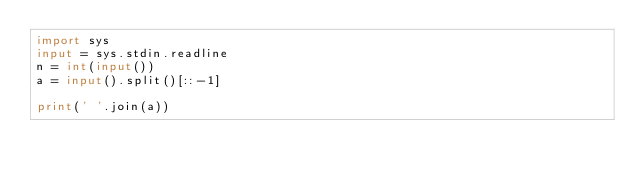Convert code to text. <code><loc_0><loc_0><loc_500><loc_500><_Python_>import sys
input = sys.stdin.readline
n = int(input())
a = input().split()[::-1]

print(' '.join(a))

</code> 